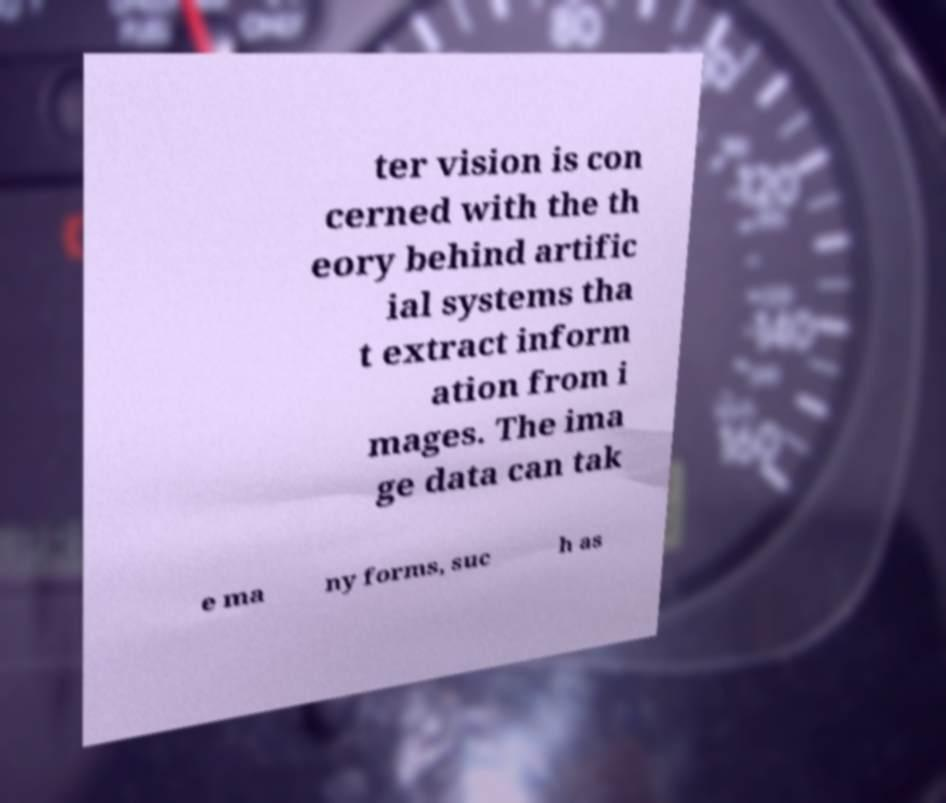What messages or text are displayed in this image? I need them in a readable, typed format. ter vision is con cerned with the th eory behind artific ial systems tha t extract inform ation from i mages. The ima ge data can tak e ma ny forms, suc h as 